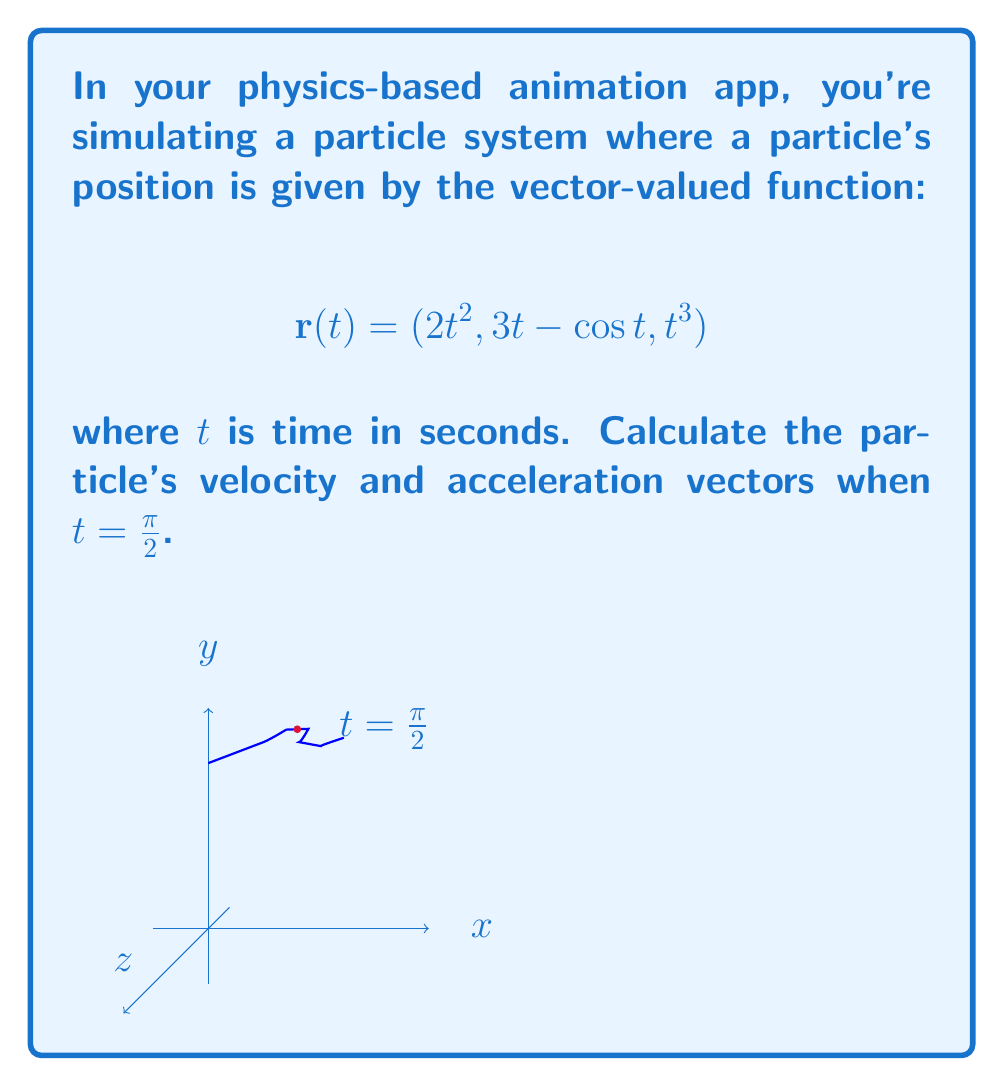Solve this math problem. Let's approach this step-by-step:

1) The velocity vector $\mathbf{v}(t)$ is the first derivative of the position vector $\mathbf{r}(t)$:

   $$\mathbf{v}(t) = \frac{d\mathbf{r}}{dt} = (4t, 3 + \sin t, 3t^2)$$

2) The acceleration vector $\mathbf{a}(t)$ is the second derivative of the position vector or the first derivative of the velocity vector:

   $$\mathbf{a}(t) = \frac{d\mathbf{v}}{dt} = (4, \cos t, 6t)$$

3) Now, we need to evaluate these at $t = \frac{\pi}{2}$:

   For velocity:
   $$\mathbf{v}(\frac{\pi}{2}) = (4 \cdot \frac{\pi}{2}, 3 + \sin \frac{\pi}{2}, 3 \cdot (\frac{\pi}{2})^2)$$
   $$= (2\pi, 4, \frac{3\pi^2}{4})$$

   For acceleration:
   $$\mathbf{a}(\frac{\pi}{2}) = (4, \cos \frac{\pi}{2}, 6 \cdot \frac{\pi}{2})$$
   $$= (4, 0, 3\pi)$$

4) These vectors represent the instantaneous velocity and acceleration of the particle at $t = \frac{\pi}{2}$ in your animation.
Answer: Velocity: $(2\pi, 4, \frac{3\pi^2}{4})$; Acceleration: $(4, 0, 3\pi)$ 